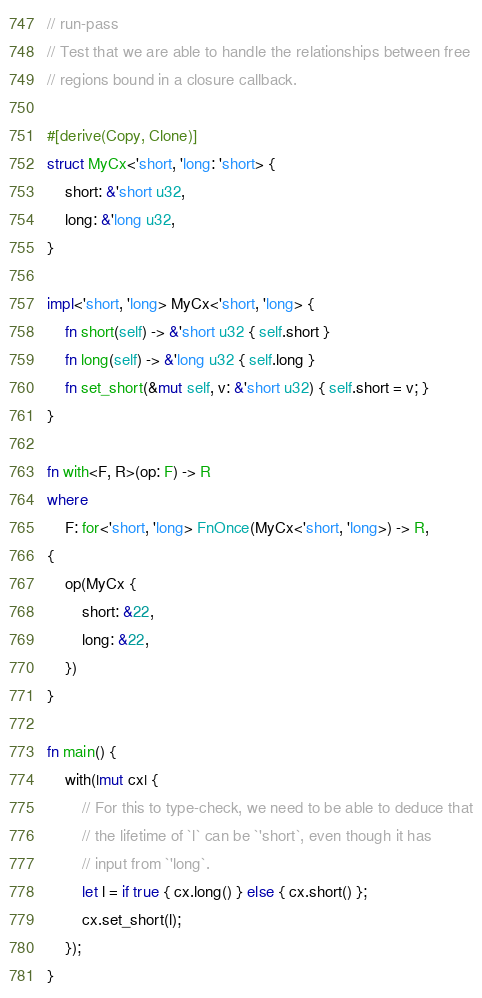<code> <loc_0><loc_0><loc_500><loc_500><_Rust_>// run-pass
// Test that we are able to handle the relationships between free
// regions bound in a closure callback.

#[derive(Copy, Clone)]
struct MyCx<'short, 'long: 'short> {
    short: &'short u32,
    long: &'long u32,
}

impl<'short, 'long> MyCx<'short, 'long> {
    fn short(self) -> &'short u32 { self.short }
    fn long(self) -> &'long u32 { self.long }
    fn set_short(&mut self, v: &'short u32) { self.short = v; }
}

fn with<F, R>(op: F) -> R
where
    F: for<'short, 'long> FnOnce(MyCx<'short, 'long>) -> R,
{
    op(MyCx {
        short: &22,
        long: &22,
    })
}

fn main() {
    with(|mut cx| {
        // For this to type-check, we need to be able to deduce that
        // the lifetime of `l` can be `'short`, even though it has
        // input from `'long`.
        let l = if true { cx.long() } else { cx.short() };
        cx.set_short(l);
    });
}
</code> 